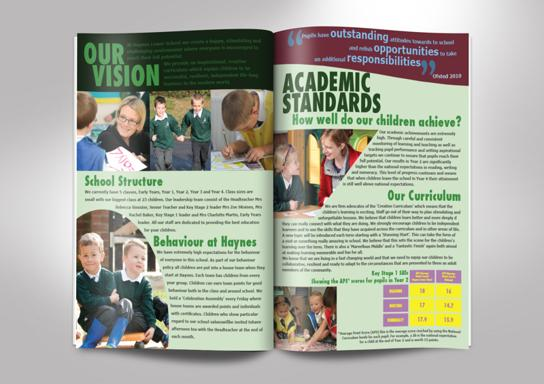What is the text discussing in regards to the school? The text in the image elaborately discusses the school's vision emphasizing a nurturing and inclusive environment. The academic section highlights the impressive achievements of the students in various assessments, showcasing the high standards maintained. It proudly mentions the school's framework focusing on outstanding opportunities and responsibilities endowed to the students, suggesting a well-rounded educational approach. 